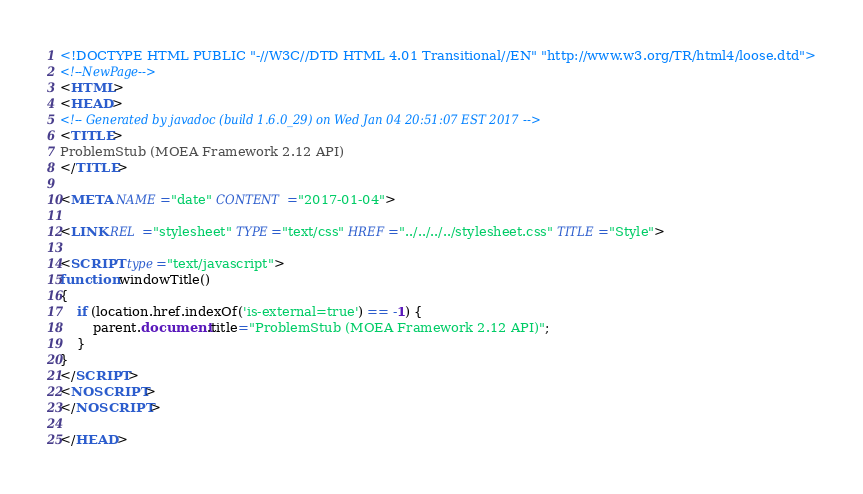<code> <loc_0><loc_0><loc_500><loc_500><_HTML_><!DOCTYPE HTML PUBLIC "-//W3C//DTD HTML 4.01 Transitional//EN" "http://www.w3.org/TR/html4/loose.dtd">
<!--NewPage-->
<HTML>
<HEAD>
<!-- Generated by javadoc (build 1.6.0_29) on Wed Jan 04 20:51:07 EST 2017 -->
<TITLE>
ProblemStub (MOEA Framework 2.12 API)
</TITLE>

<META NAME="date" CONTENT="2017-01-04">

<LINK REL ="stylesheet" TYPE="text/css" HREF="../../../../stylesheet.css" TITLE="Style">

<SCRIPT type="text/javascript">
function windowTitle()
{
    if (location.href.indexOf('is-external=true') == -1) {
        parent.document.title="ProblemStub (MOEA Framework 2.12 API)";
    }
}
</SCRIPT>
<NOSCRIPT>
</NOSCRIPT>

</HEAD>
</code> 